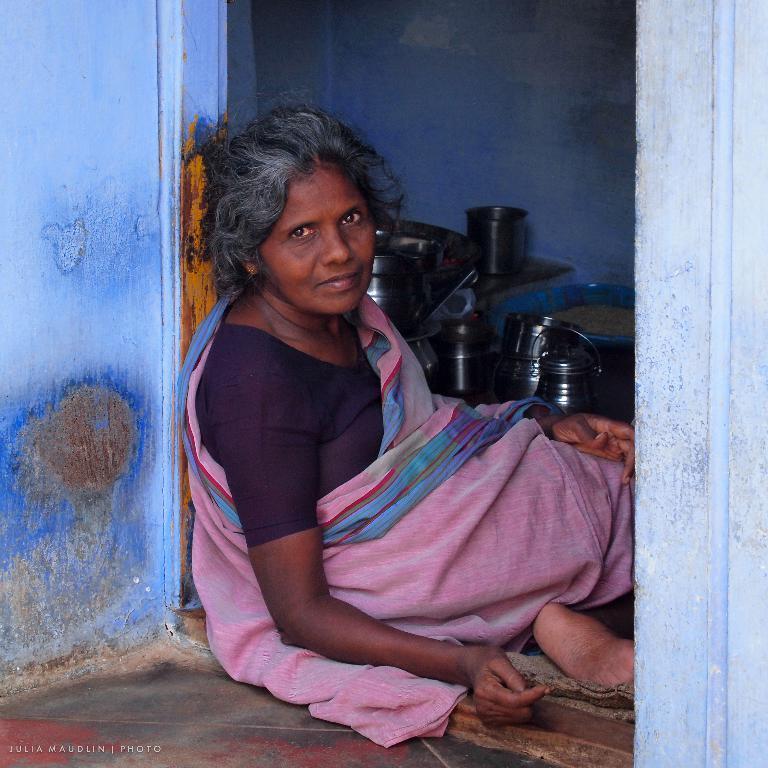Can you describe this image briefly? In the picture we can see a blue color house near the door, we can see a woman sitting and inside the house we can see some steel items. 